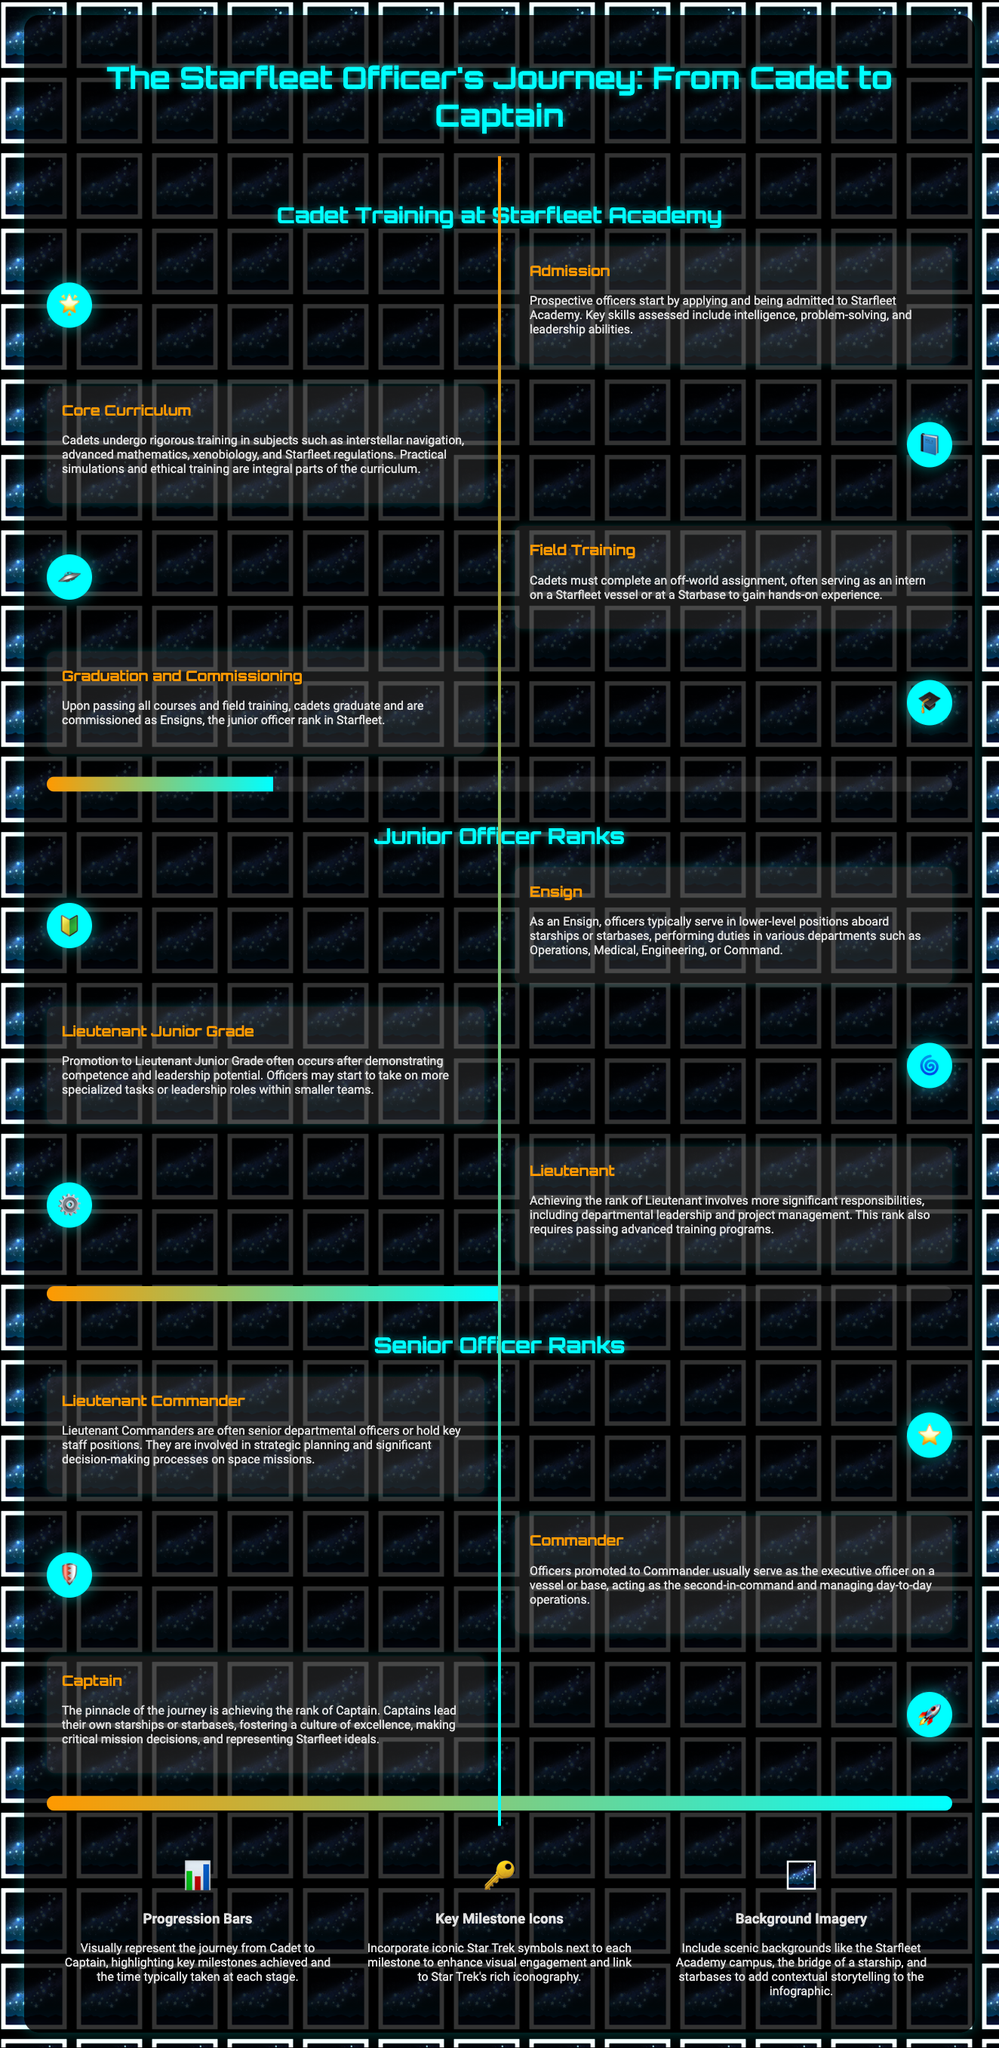What is the first step in the Starfleet Officer's journey? The first step is admission to Starfleet Academy.
Answer: Admission What rank do cadets receive upon graduation? Upon graduation, cadets are commissioned as Ensigns.
Answer: Ensigns What is the percentage completion of the timeline at the graduation milestone? The timeline completion at graduation is indicated as 25%.
Answer: 25% What rank directly follows Lieutenant? The rank that follows Lieutenant is Lieutenant Commander.
Answer: Lieutenant Commander Which icon represents the Core Curriculum milestone? The Core Curriculum milestone is represented by the book icon 📘.
Answer: 📘 What is the final rank in the progression depicted in the infographic? The final rank is Captain.
Answer: Captain How many junior officer ranks are listed in the document? There are three junior officer ranks listed in the document.
Answer: Three What percentage of the journey is represented at the Captain rank? The percentage of the journey at the Captain rank is 100%.
Answer: 100% Which design element is focused on showing journey progress? The design element focused on showing journey progress is Progression Bars.
Answer: Progression Bars 